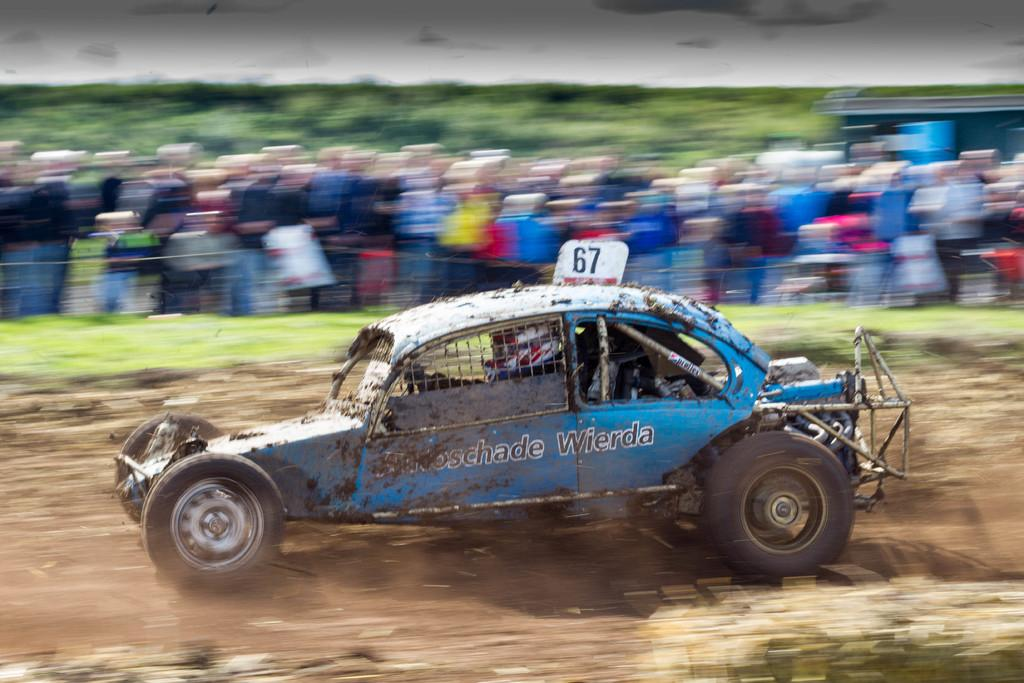What is the main subject of the image? There is a car in the image. What color is the car? The car is blue in color. Who is operating the car? A person is driving the car. Can you describe the background of the image? The background of the image is blurred. What thought is the car having while driving down the road? Cars do not have thoughts, as they are inanimate objects. 